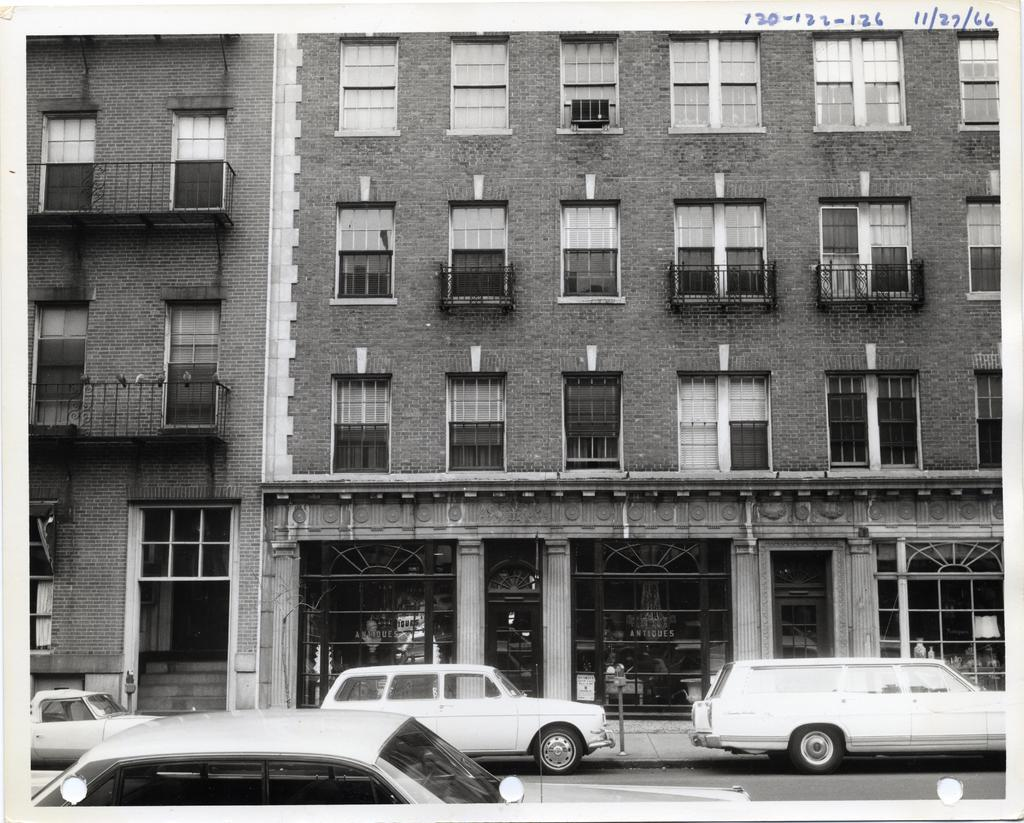What is the color scheme of the image? The image is black and white. What type of structure can be seen in the image? There is a building with windows in the image. What object is present near the building? There is a pole in the image. What mode of transportation can be seen in the image? There is a group of cars on the road in the image. What is written or displayed at the top of the image? There is some text visible at the top of the image. Can you see a tent set up near the building in the image? No, there is no tent present in the image. What type of cream is being used to paint the pole in the image? There is no cream or painting activity visible in the image; the pole is just a plain object. 